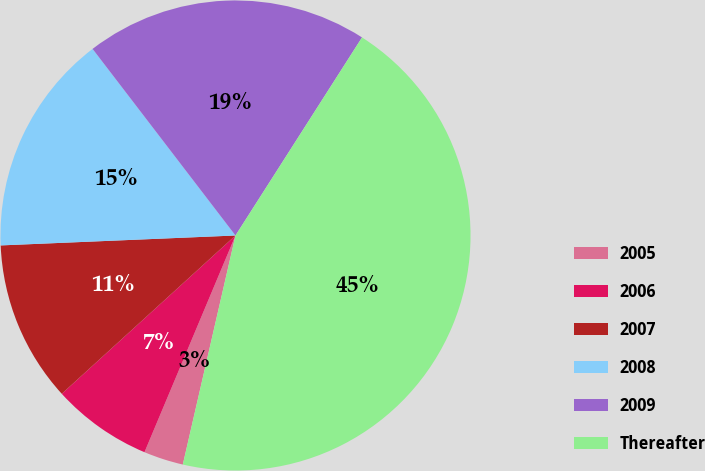Convert chart. <chart><loc_0><loc_0><loc_500><loc_500><pie_chart><fcel>2005<fcel>2006<fcel>2007<fcel>2008<fcel>2009<fcel>Thereafter<nl><fcel>2.73%<fcel>6.91%<fcel>11.09%<fcel>15.27%<fcel>19.45%<fcel>44.55%<nl></chart> 